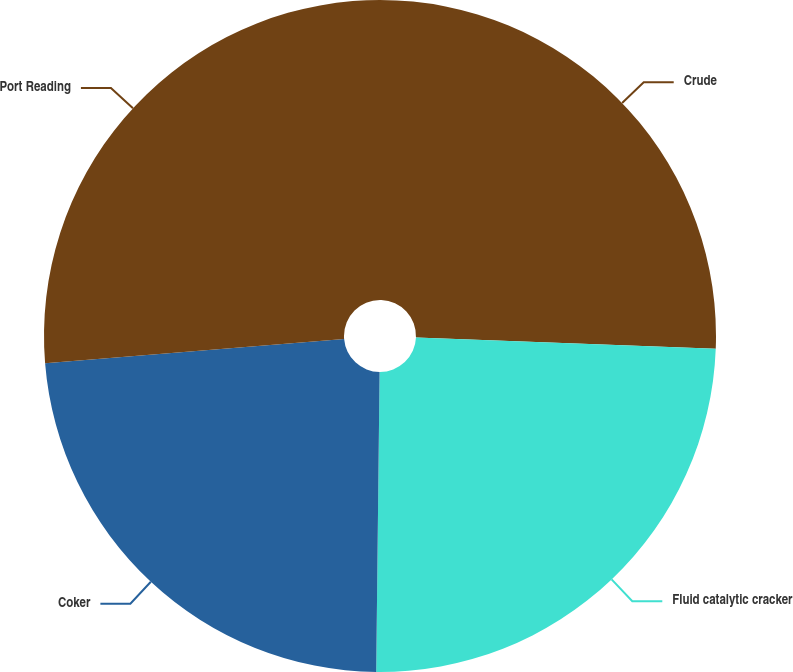Convert chart to OTSL. <chart><loc_0><loc_0><loc_500><loc_500><pie_chart><fcel>Crude<fcel>Fluid catalytic cracker<fcel>Coker<fcel>Port Reading<nl><fcel>25.61%<fcel>24.57%<fcel>23.53%<fcel>26.29%<nl></chart> 